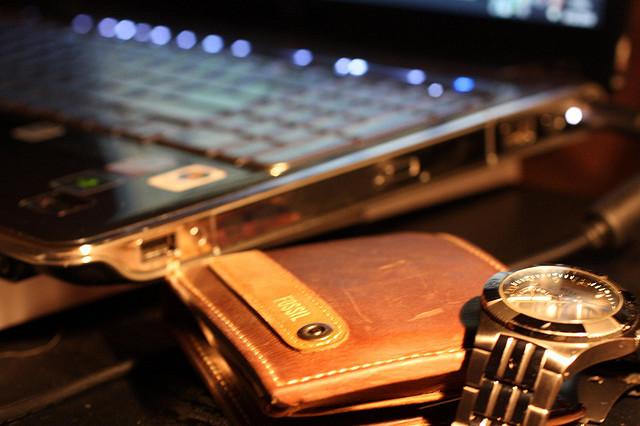Does the watch have a rubber band?
Keep it brief. No. What type of computer is on the desk?
Short answer required. Laptop. Is there a laptop in this picture?
Concise answer only. Yes. 